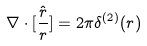<formula> <loc_0><loc_0><loc_500><loc_500>\nabla \cdot [ \frac { \hat { r } } { r } ] = 2 \pi \delta ^ { ( 2 ) } ( r )</formula> 